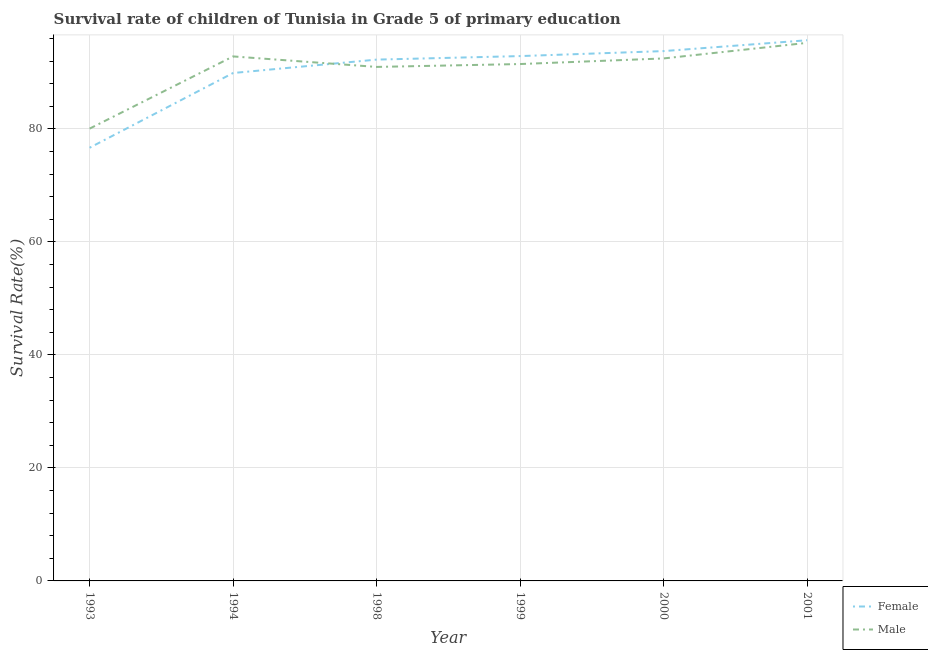Does the line corresponding to survival rate of female students in primary education intersect with the line corresponding to survival rate of male students in primary education?
Provide a succinct answer. Yes. What is the survival rate of female students in primary education in 2001?
Your response must be concise. 95.69. Across all years, what is the maximum survival rate of female students in primary education?
Offer a very short reply. 95.69. Across all years, what is the minimum survival rate of male students in primary education?
Your answer should be very brief. 80.05. In which year was the survival rate of male students in primary education maximum?
Keep it short and to the point. 2001. In which year was the survival rate of female students in primary education minimum?
Keep it short and to the point. 1993. What is the total survival rate of male students in primary education in the graph?
Provide a succinct answer. 543.05. What is the difference between the survival rate of male students in primary education in 1993 and that in 1999?
Give a very brief answer. -11.43. What is the difference between the survival rate of female students in primary education in 2001 and the survival rate of male students in primary education in 1999?
Give a very brief answer. 4.21. What is the average survival rate of female students in primary education per year?
Ensure brevity in your answer.  90.2. In the year 2001, what is the difference between the survival rate of female students in primary education and survival rate of male students in primary education?
Provide a succinct answer. 0.46. In how many years, is the survival rate of male students in primary education greater than 56 %?
Offer a very short reply. 6. What is the ratio of the survival rate of male students in primary education in 1994 to that in 1998?
Make the answer very short. 1.02. Is the difference between the survival rate of male students in primary education in 1999 and 2000 greater than the difference between the survival rate of female students in primary education in 1999 and 2000?
Provide a succinct answer. No. What is the difference between the highest and the second highest survival rate of female students in primary education?
Give a very brief answer. 1.92. What is the difference between the highest and the lowest survival rate of female students in primary education?
Provide a short and direct response. 19.03. Is the sum of the survival rate of male students in primary education in 1999 and 2001 greater than the maximum survival rate of female students in primary education across all years?
Your answer should be very brief. Yes. Is the survival rate of female students in primary education strictly less than the survival rate of male students in primary education over the years?
Your response must be concise. No. Are the values on the major ticks of Y-axis written in scientific E-notation?
Give a very brief answer. No. Where does the legend appear in the graph?
Ensure brevity in your answer.  Bottom right. How many legend labels are there?
Make the answer very short. 2. How are the legend labels stacked?
Ensure brevity in your answer.  Vertical. What is the title of the graph?
Provide a succinct answer. Survival rate of children of Tunisia in Grade 5 of primary education. Does "Diesel" appear as one of the legend labels in the graph?
Your answer should be very brief. No. What is the label or title of the Y-axis?
Give a very brief answer. Survival Rate(%). What is the Survival Rate(%) of Female in 1993?
Your answer should be compact. 76.67. What is the Survival Rate(%) in Male in 1993?
Provide a succinct answer. 80.05. What is the Survival Rate(%) in Female in 1994?
Provide a succinct answer. 89.9. What is the Survival Rate(%) of Male in 1994?
Offer a terse response. 92.83. What is the Survival Rate(%) in Female in 1998?
Provide a succinct answer. 92.27. What is the Survival Rate(%) in Male in 1998?
Provide a short and direct response. 90.97. What is the Survival Rate(%) of Female in 1999?
Keep it short and to the point. 92.89. What is the Survival Rate(%) in Male in 1999?
Ensure brevity in your answer.  91.48. What is the Survival Rate(%) in Female in 2000?
Keep it short and to the point. 93.78. What is the Survival Rate(%) in Male in 2000?
Offer a terse response. 92.48. What is the Survival Rate(%) in Female in 2001?
Provide a succinct answer. 95.69. What is the Survival Rate(%) of Male in 2001?
Keep it short and to the point. 95.23. Across all years, what is the maximum Survival Rate(%) of Female?
Your response must be concise. 95.69. Across all years, what is the maximum Survival Rate(%) of Male?
Keep it short and to the point. 95.23. Across all years, what is the minimum Survival Rate(%) in Female?
Your answer should be compact. 76.67. Across all years, what is the minimum Survival Rate(%) of Male?
Your answer should be very brief. 80.05. What is the total Survival Rate(%) of Female in the graph?
Provide a succinct answer. 541.19. What is the total Survival Rate(%) of Male in the graph?
Give a very brief answer. 543.05. What is the difference between the Survival Rate(%) of Female in 1993 and that in 1994?
Keep it short and to the point. -13.23. What is the difference between the Survival Rate(%) of Male in 1993 and that in 1994?
Offer a very short reply. -12.78. What is the difference between the Survival Rate(%) in Female in 1993 and that in 1998?
Make the answer very short. -15.6. What is the difference between the Survival Rate(%) of Male in 1993 and that in 1998?
Offer a terse response. -10.92. What is the difference between the Survival Rate(%) in Female in 1993 and that in 1999?
Make the answer very short. -16.22. What is the difference between the Survival Rate(%) in Male in 1993 and that in 1999?
Offer a terse response. -11.43. What is the difference between the Survival Rate(%) of Female in 1993 and that in 2000?
Make the answer very short. -17.11. What is the difference between the Survival Rate(%) in Male in 1993 and that in 2000?
Give a very brief answer. -12.42. What is the difference between the Survival Rate(%) of Female in 1993 and that in 2001?
Provide a succinct answer. -19.03. What is the difference between the Survival Rate(%) of Male in 1993 and that in 2001?
Give a very brief answer. -15.18. What is the difference between the Survival Rate(%) in Female in 1994 and that in 1998?
Your answer should be very brief. -2.37. What is the difference between the Survival Rate(%) of Male in 1994 and that in 1998?
Give a very brief answer. 1.86. What is the difference between the Survival Rate(%) of Female in 1994 and that in 1999?
Keep it short and to the point. -2.99. What is the difference between the Survival Rate(%) in Male in 1994 and that in 1999?
Your answer should be compact. 1.35. What is the difference between the Survival Rate(%) of Female in 1994 and that in 2000?
Give a very brief answer. -3.88. What is the difference between the Survival Rate(%) of Male in 1994 and that in 2000?
Provide a short and direct response. 0.36. What is the difference between the Survival Rate(%) in Female in 1994 and that in 2001?
Give a very brief answer. -5.8. What is the difference between the Survival Rate(%) of Female in 1998 and that in 1999?
Your answer should be very brief. -0.62. What is the difference between the Survival Rate(%) in Male in 1998 and that in 1999?
Ensure brevity in your answer.  -0.51. What is the difference between the Survival Rate(%) in Female in 1998 and that in 2000?
Make the answer very short. -1.51. What is the difference between the Survival Rate(%) in Male in 1998 and that in 2000?
Make the answer very short. -1.5. What is the difference between the Survival Rate(%) of Female in 1998 and that in 2001?
Offer a very short reply. -3.43. What is the difference between the Survival Rate(%) in Male in 1998 and that in 2001?
Your response must be concise. -4.26. What is the difference between the Survival Rate(%) in Female in 1999 and that in 2000?
Provide a succinct answer. -0.88. What is the difference between the Survival Rate(%) of Male in 1999 and that in 2000?
Your answer should be compact. -0.99. What is the difference between the Survival Rate(%) in Female in 1999 and that in 2001?
Provide a short and direct response. -2.8. What is the difference between the Survival Rate(%) in Male in 1999 and that in 2001?
Your response must be concise. -3.75. What is the difference between the Survival Rate(%) of Female in 2000 and that in 2001?
Your answer should be very brief. -1.92. What is the difference between the Survival Rate(%) of Male in 2000 and that in 2001?
Provide a succinct answer. -2.76. What is the difference between the Survival Rate(%) in Female in 1993 and the Survival Rate(%) in Male in 1994?
Provide a succinct answer. -16.17. What is the difference between the Survival Rate(%) in Female in 1993 and the Survival Rate(%) in Male in 1998?
Keep it short and to the point. -14.31. What is the difference between the Survival Rate(%) of Female in 1993 and the Survival Rate(%) of Male in 1999?
Provide a short and direct response. -14.82. What is the difference between the Survival Rate(%) of Female in 1993 and the Survival Rate(%) of Male in 2000?
Keep it short and to the point. -15.81. What is the difference between the Survival Rate(%) of Female in 1993 and the Survival Rate(%) of Male in 2001?
Offer a very short reply. -18.57. What is the difference between the Survival Rate(%) of Female in 1994 and the Survival Rate(%) of Male in 1998?
Make the answer very short. -1.08. What is the difference between the Survival Rate(%) in Female in 1994 and the Survival Rate(%) in Male in 1999?
Offer a terse response. -1.59. What is the difference between the Survival Rate(%) in Female in 1994 and the Survival Rate(%) in Male in 2000?
Offer a very short reply. -2.58. What is the difference between the Survival Rate(%) in Female in 1994 and the Survival Rate(%) in Male in 2001?
Ensure brevity in your answer.  -5.34. What is the difference between the Survival Rate(%) in Female in 1998 and the Survival Rate(%) in Male in 1999?
Offer a very short reply. 0.78. What is the difference between the Survival Rate(%) in Female in 1998 and the Survival Rate(%) in Male in 2000?
Your response must be concise. -0.21. What is the difference between the Survival Rate(%) of Female in 1998 and the Survival Rate(%) of Male in 2001?
Provide a succinct answer. -2.97. What is the difference between the Survival Rate(%) of Female in 1999 and the Survival Rate(%) of Male in 2000?
Provide a short and direct response. 0.42. What is the difference between the Survival Rate(%) in Female in 1999 and the Survival Rate(%) in Male in 2001?
Your response must be concise. -2.34. What is the difference between the Survival Rate(%) of Female in 2000 and the Survival Rate(%) of Male in 2001?
Offer a terse response. -1.46. What is the average Survival Rate(%) of Female per year?
Your answer should be very brief. 90.2. What is the average Survival Rate(%) of Male per year?
Offer a terse response. 90.51. In the year 1993, what is the difference between the Survival Rate(%) of Female and Survival Rate(%) of Male?
Give a very brief answer. -3.38. In the year 1994, what is the difference between the Survival Rate(%) in Female and Survival Rate(%) in Male?
Offer a terse response. -2.94. In the year 1998, what is the difference between the Survival Rate(%) of Female and Survival Rate(%) of Male?
Offer a very short reply. 1.29. In the year 1999, what is the difference between the Survival Rate(%) of Female and Survival Rate(%) of Male?
Your response must be concise. 1.41. In the year 2000, what is the difference between the Survival Rate(%) of Female and Survival Rate(%) of Male?
Give a very brief answer. 1.3. In the year 2001, what is the difference between the Survival Rate(%) in Female and Survival Rate(%) in Male?
Make the answer very short. 0.46. What is the ratio of the Survival Rate(%) in Female in 1993 to that in 1994?
Your answer should be very brief. 0.85. What is the ratio of the Survival Rate(%) in Male in 1993 to that in 1994?
Offer a very short reply. 0.86. What is the ratio of the Survival Rate(%) in Female in 1993 to that in 1998?
Make the answer very short. 0.83. What is the ratio of the Survival Rate(%) of Male in 1993 to that in 1998?
Give a very brief answer. 0.88. What is the ratio of the Survival Rate(%) in Female in 1993 to that in 1999?
Keep it short and to the point. 0.83. What is the ratio of the Survival Rate(%) of Female in 1993 to that in 2000?
Provide a succinct answer. 0.82. What is the ratio of the Survival Rate(%) of Male in 1993 to that in 2000?
Your answer should be very brief. 0.87. What is the ratio of the Survival Rate(%) of Female in 1993 to that in 2001?
Your answer should be very brief. 0.8. What is the ratio of the Survival Rate(%) of Male in 1993 to that in 2001?
Give a very brief answer. 0.84. What is the ratio of the Survival Rate(%) of Female in 1994 to that in 1998?
Make the answer very short. 0.97. What is the ratio of the Survival Rate(%) of Male in 1994 to that in 1998?
Give a very brief answer. 1.02. What is the ratio of the Survival Rate(%) of Female in 1994 to that in 1999?
Offer a very short reply. 0.97. What is the ratio of the Survival Rate(%) in Male in 1994 to that in 1999?
Offer a very short reply. 1.01. What is the ratio of the Survival Rate(%) in Female in 1994 to that in 2000?
Ensure brevity in your answer.  0.96. What is the ratio of the Survival Rate(%) in Female in 1994 to that in 2001?
Make the answer very short. 0.94. What is the ratio of the Survival Rate(%) in Male in 1994 to that in 2001?
Your response must be concise. 0.97. What is the ratio of the Survival Rate(%) of Female in 1998 to that in 1999?
Offer a terse response. 0.99. What is the ratio of the Survival Rate(%) in Female in 1998 to that in 2000?
Offer a very short reply. 0.98. What is the ratio of the Survival Rate(%) of Male in 1998 to that in 2000?
Offer a very short reply. 0.98. What is the ratio of the Survival Rate(%) of Female in 1998 to that in 2001?
Your answer should be very brief. 0.96. What is the ratio of the Survival Rate(%) of Male in 1998 to that in 2001?
Give a very brief answer. 0.96. What is the ratio of the Survival Rate(%) in Female in 1999 to that in 2000?
Make the answer very short. 0.99. What is the ratio of the Survival Rate(%) in Male in 1999 to that in 2000?
Make the answer very short. 0.99. What is the ratio of the Survival Rate(%) of Female in 1999 to that in 2001?
Ensure brevity in your answer.  0.97. What is the ratio of the Survival Rate(%) of Male in 1999 to that in 2001?
Your answer should be compact. 0.96. What is the ratio of the Survival Rate(%) in Male in 2000 to that in 2001?
Your answer should be very brief. 0.97. What is the difference between the highest and the second highest Survival Rate(%) of Female?
Ensure brevity in your answer.  1.92. What is the difference between the highest and the second highest Survival Rate(%) of Male?
Your response must be concise. 2.4. What is the difference between the highest and the lowest Survival Rate(%) in Female?
Your answer should be very brief. 19.03. What is the difference between the highest and the lowest Survival Rate(%) of Male?
Your answer should be compact. 15.18. 